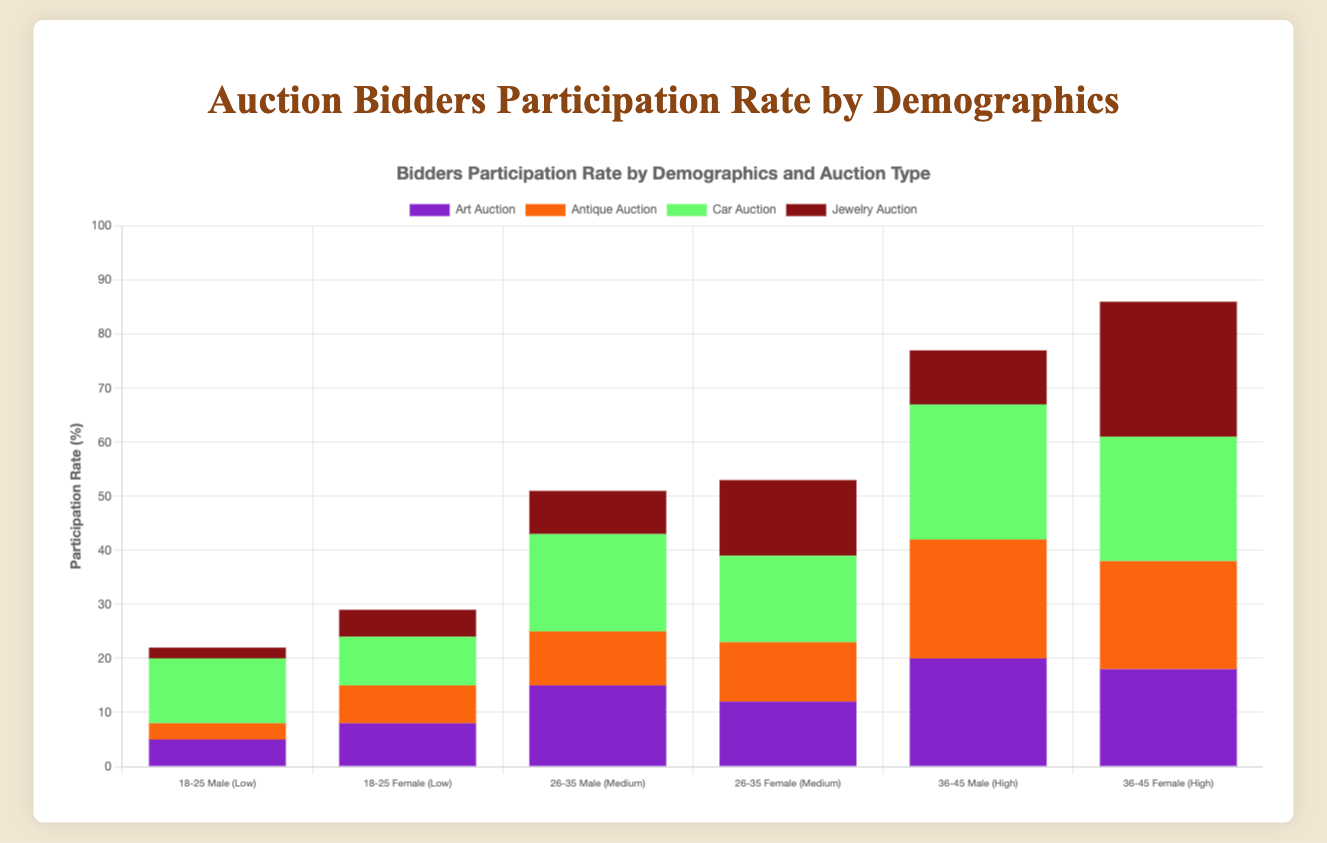Which auction type has the highest participation rate for the 36-45 age group with high income, comparing both genders? For the 36-45 age group with high income, identify the participation rates for both males and females across all auction types. Car Auction has the highest participation rates for both males (25) and females (23).
Answer: Car Auction Which age-range and gender combination has the lowest participation rate in Art Auctions? In Art Auctions, compare the participation rates of different age ranges and genders. The 18-25 age range for males has the lowest participation rate, which is 5.
Answer: 18-25 males Compare the participation rates of males aged 26-35 in the Medium income level across all auction types. Which auction type has the highest rate? For males aged 26-35 with Medium income, the participation rates are as follows: Art Auction - 15, Antique Auction - 10, Car Auction - 18, Jewelry Auction - 8. The Car Auction has the highest rate.
Answer: Car Auction What's the total participation rate for females aged 18-25 with Low income across all auction types? Sum the participation rates for females aged 18-25 with Low income: Art Auction - 8, Antique Auction - 7, Car Auction - 9, Jewelry Auction - 5. The total participation rate is 8 + 7 + 9 + 5 = 29.
Answer: 29 Which demographics show equal participation rates for Art and Jewelry Auctions in the 36-45 age group with High income? Compare participation rates in the 36-45 age group for both genders with High income in Art and Jewelry Auctions. Females show equal participation rates of 18 in both auctions.
Answer: Females What is the combined participation rate for males aged 36-45 with High income in all auctions? Add the participation rates for males aged 36-45 with High income in all auctions: Art Auction - 20, Antique Auction - 22, Car Auction - 25, Jewelry Auction - 10. The combined rate is 20 + 22 + 25 + 10 = 77.
Answer: 77 Compare participation rate trends of participants aged 18-25 with Low income in Art and Car Auctions. Which trend is observed? Compare participation rates: Art Auction - Males: 5, Females: 8; Car Auction - Males: 12, Females: 9. Both genders have a higher participation rate in Car Auctions compared to Art Auctions.
Answer: Higher in Car Auctions 